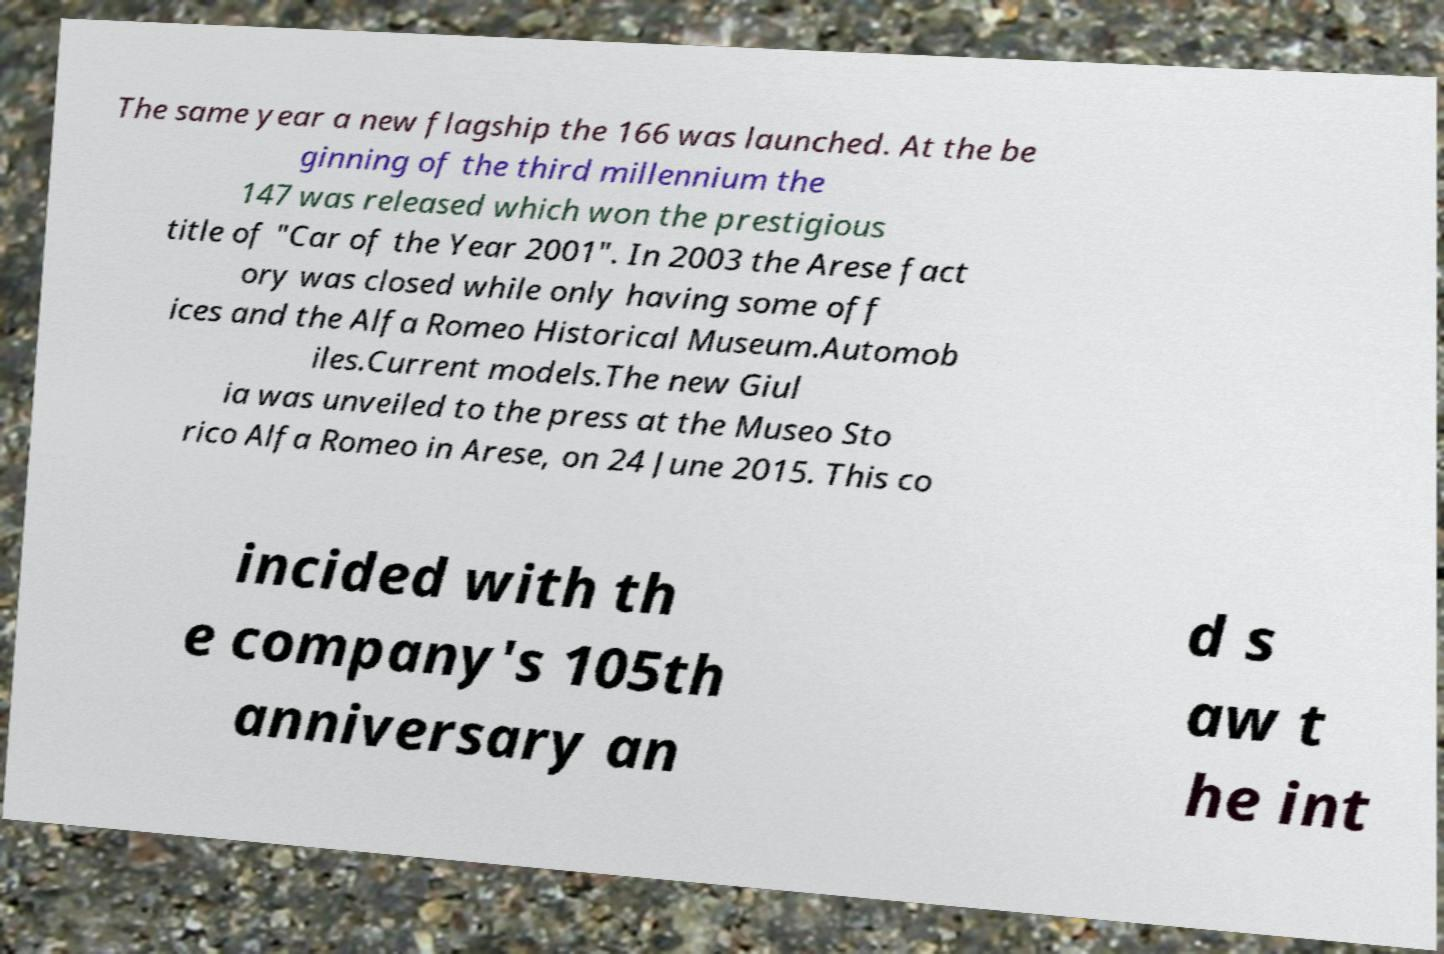Please identify and transcribe the text found in this image. The same year a new flagship the 166 was launched. At the be ginning of the third millennium the 147 was released which won the prestigious title of "Car of the Year 2001". In 2003 the Arese fact ory was closed while only having some off ices and the Alfa Romeo Historical Museum.Automob iles.Current models.The new Giul ia was unveiled to the press at the Museo Sto rico Alfa Romeo in Arese, on 24 June 2015. This co incided with th e company's 105th anniversary an d s aw t he int 